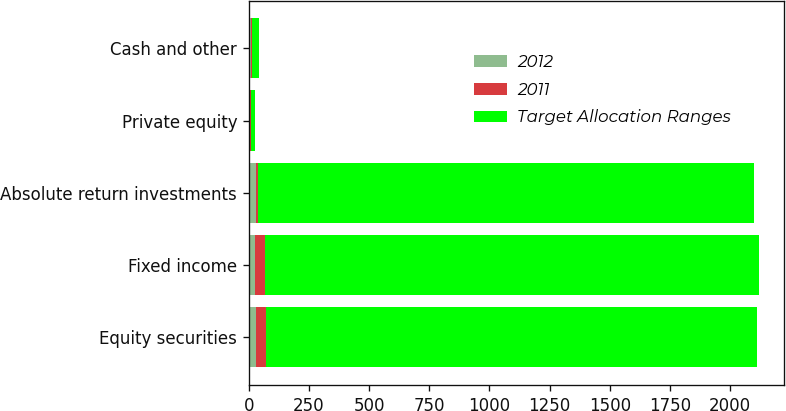Convert chart to OTSL. <chart><loc_0><loc_0><loc_500><loc_500><stacked_bar_chart><ecel><fcel>Equity securities<fcel>Fixed income<fcel>Absolute return investments<fcel>Private equity<fcel>Cash and other<nl><fcel>2012<fcel>29.2<fcel>26.4<fcel>29.4<fcel>5.1<fcel>9.9<nl><fcel>2011<fcel>42.2<fcel>41.5<fcel>8.9<fcel>5.8<fcel>1.6<nl><fcel>Target Allocation Ranges<fcel>2040<fcel>2050<fcel>2060<fcel>15<fcel>30<nl></chart> 